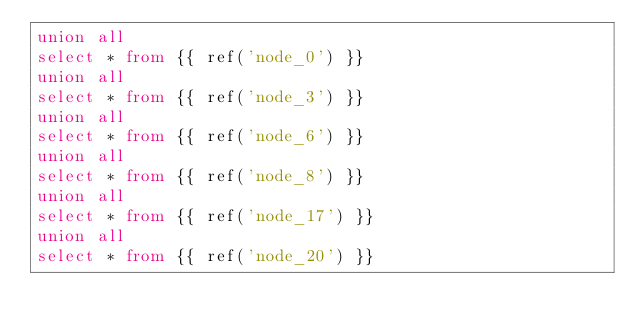<code> <loc_0><loc_0><loc_500><loc_500><_SQL_>union all
select * from {{ ref('node_0') }}
union all
select * from {{ ref('node_3') }}
union all
select * from {{ ref('node_6') }}
union all
select * from {{ ref('node_8') }}
union all
select * from {{ ref('node_17') }}
union all
select * from {{ ref('node_20') }}</code> 